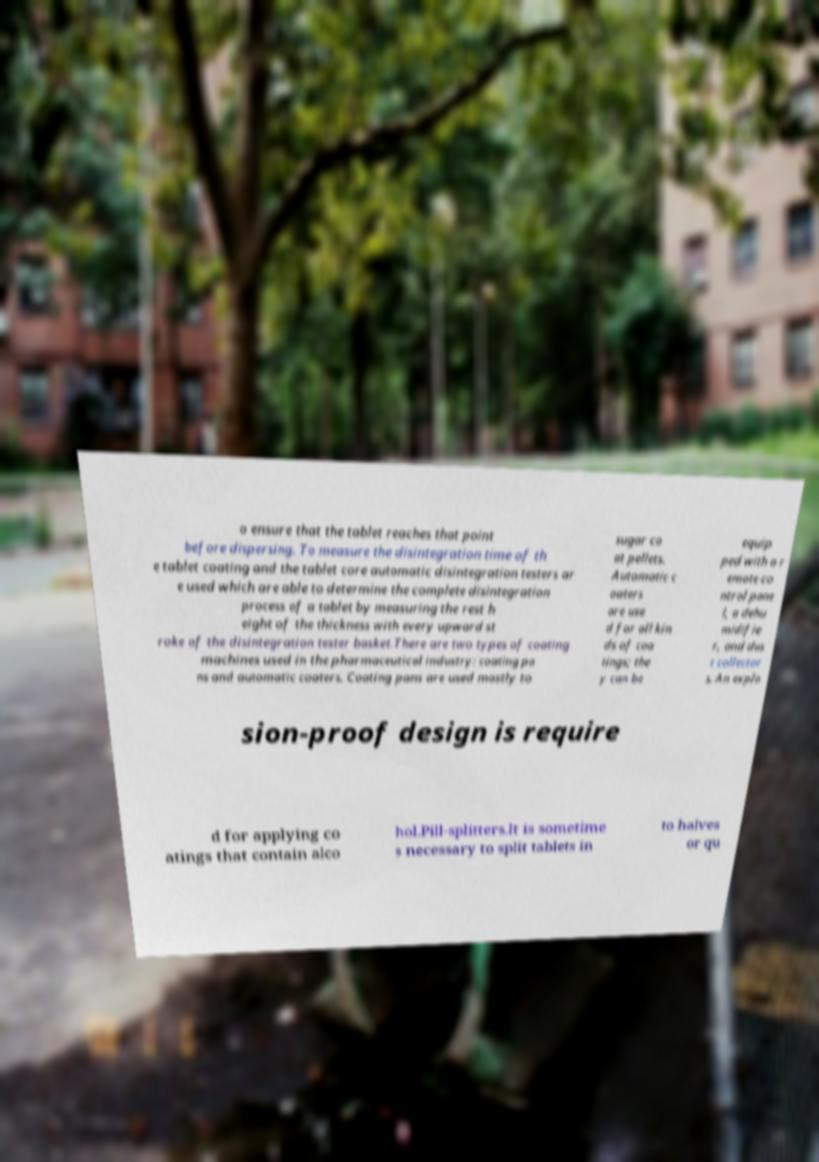Please identify and transcribe the text found in this image. o ensure that the tablet reaches that point before dispersing. To measure the disintegration time of th e tablet coating and the tablet core automatic disintegration testers ar e used which are able to determine the complete disintegration process of a tablet by measuring the rest h eight of the thickness with every upward st roke of the disintegration tester basket.There are two types of coating machines used in the pharmaceutical industry: coating pa ns and automatic coaters. Coating pans are used mostly to sugar co at pellets. Automatic c oaters are use d for all kin ds of coa tings; the y can be equip ped with a r emote co ntrol pane l, a dehu midifie r, and dus t collector s. An explo sion-proof design is require d for applying co atings that contain alco hol.Pill-splitters.It is sometime s necessary to split tablets in to halves or qu 